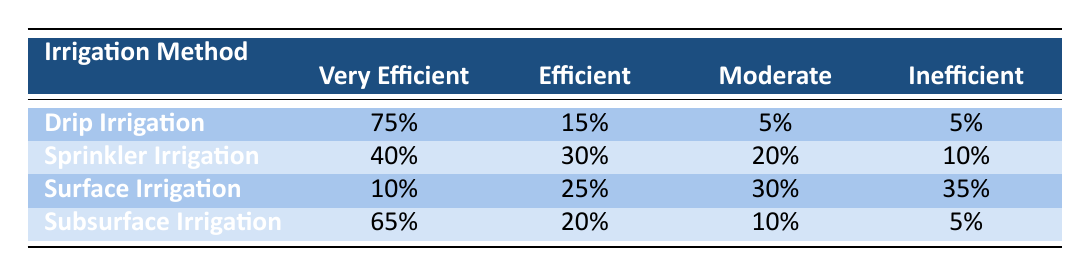What percentage of "Drip Irrigation" is classified as "Very Efficient"? According to the table, "Drip Irrigation" has a value of 75% listed under the "Very Efficient" category.
Answer: 75% How many irrigation methods have more than 60% classified as "Very Efficient"? The table shows that "Drip Irrigation" (75%) and "Subsurface Irrigation" (65%) are the only two irrigation methods with more than 60% in the "Very Efficient" category.
Answer: 2 What is the difference in percentage between "Sprinkler Irrigation" and "Surface Irrigation" in the "Inefficient" category? "Sprinkler Irrigation" has 10% classified as "Inefficient," while "Surface Irrigation" has 35%. The difference is 35% - 10% = 25%.
Answer: 25% Is "Subsurface Irrigation" more efficient than "Surface Irrigation" in the "Moderate" category? The table indicates that "Subsurface Irrigation" has 10% in the "Moderate" category, while "Surface Irrigation" has 30%. Thus, "Subsurface Irrigation" is less efficient than "Surface Irrigation" in this category.
Answer: No What is the total percentage of "Efficient" ratings across all irrigation methods? Summing the "Efficient" ratings, we have: Drip Irrigation (15%) + Sprinkler Irrigation (30%) + Surface Irrigation (25%) + Subsurface Irrigation (20%) = 90%.
Answer: 90% 